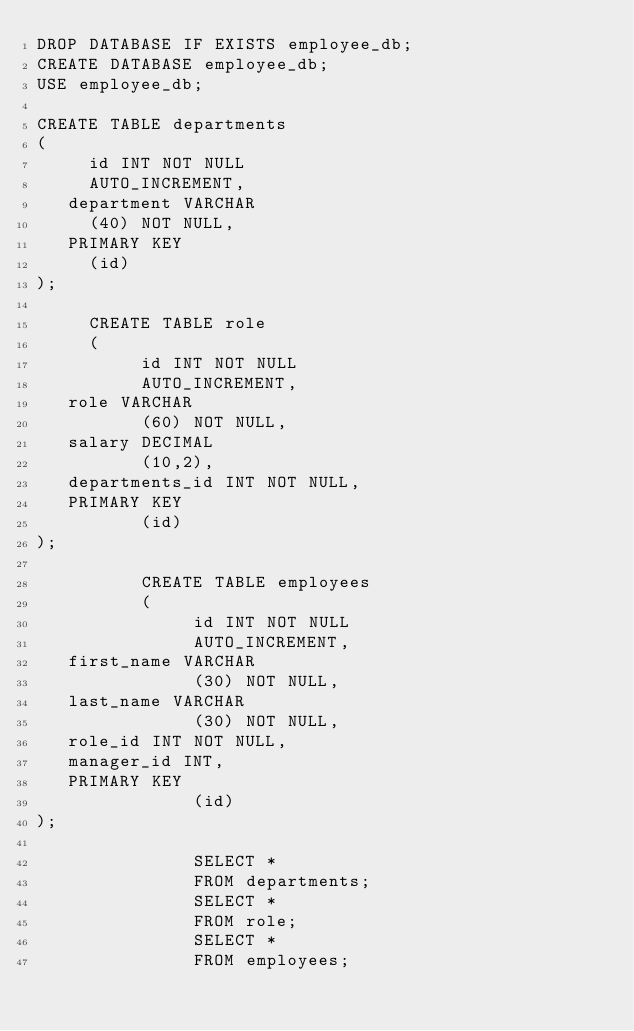Convert code to text. <code><loc_0><loc_0><loc_500><loc_500><_SQL_>DROP DATABASE IF EXISTS employee_db;
CREATE DATABASE employee_db;
USE employee_db;

CREATE TABLE departments
(
     id INT NOT NULL
     AUTO_INCREMENT,
   department VARCHAR
     (40) NOT NULL,
   PRIMARY KEY
     (id)
);

     CREATE TABLE role
     (
          id INT NOT NULL
          AUTO_INCREMENT,
   role VARCHAR
          (60) NOT NULL,
   salary DECIMAL
          (10,2),
   departments_id INT NOT NULL,
   PRIMARY KEY
          (id)
);

          CREATE TABLE employees
          (
               id INT NOT NULL
               AUTO_INCREMENT,
   first_name VARCHAR
               (30) NOT NULL,
   last_name VARCHAR
               (30) NOT NULL,
   role_id INT NOT NULL,
   manager_id INT,
   PRIMARY KEY
               (id)
);

               SELECT *
               FROM departments;
               SELECT *
               FROM role;
               SELECT *
               FROM employees;

</code> 